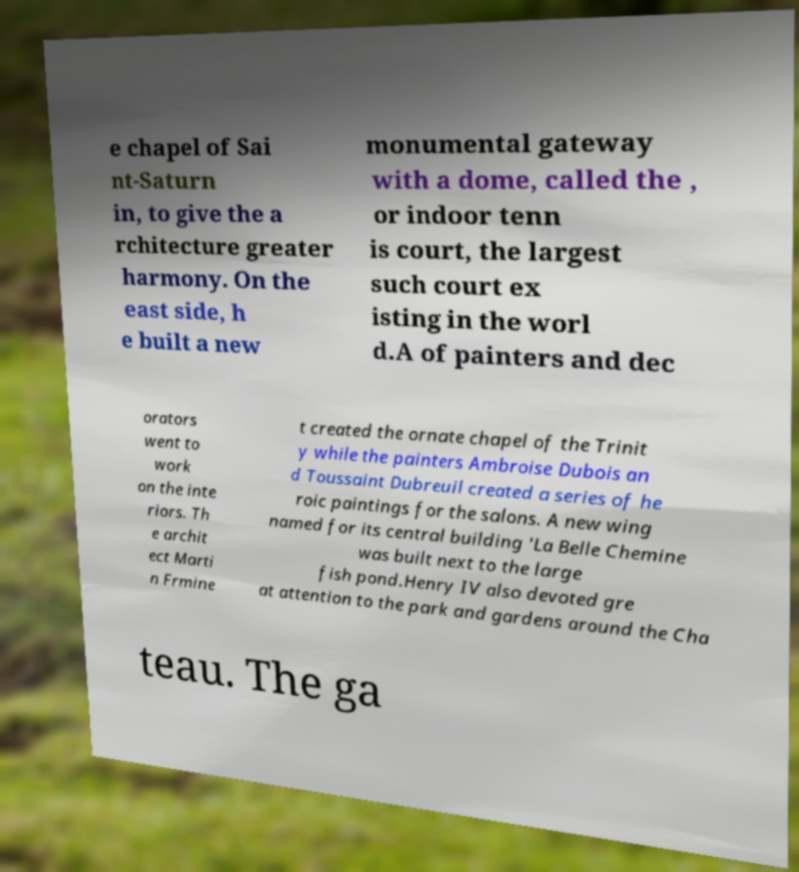For documentation purposes, I need the text within this image transcribed. Could you provide that? e chapel of Sai nt-Saturn in, to give the a rchitecture greater harmony. On the east side, h e built a new monumental gateway with a dome, called the , or indoor tenn is court, the largest such court ex isting in the worl d.A of painters and dec orators went to work on the inte riors. Th e archit ect Marti n Frmine t created the ornate chapel of the Trinit y while the painters Ambroise Dubois an d Toussaint Dubreuil created a series of he roic paintings for the salons. A new wing named for its central building 'La Belle Chemine was built next to the large fish pond.Henry IV also devoted gre at attention to the park and gardens around the Cha teau. The ga 